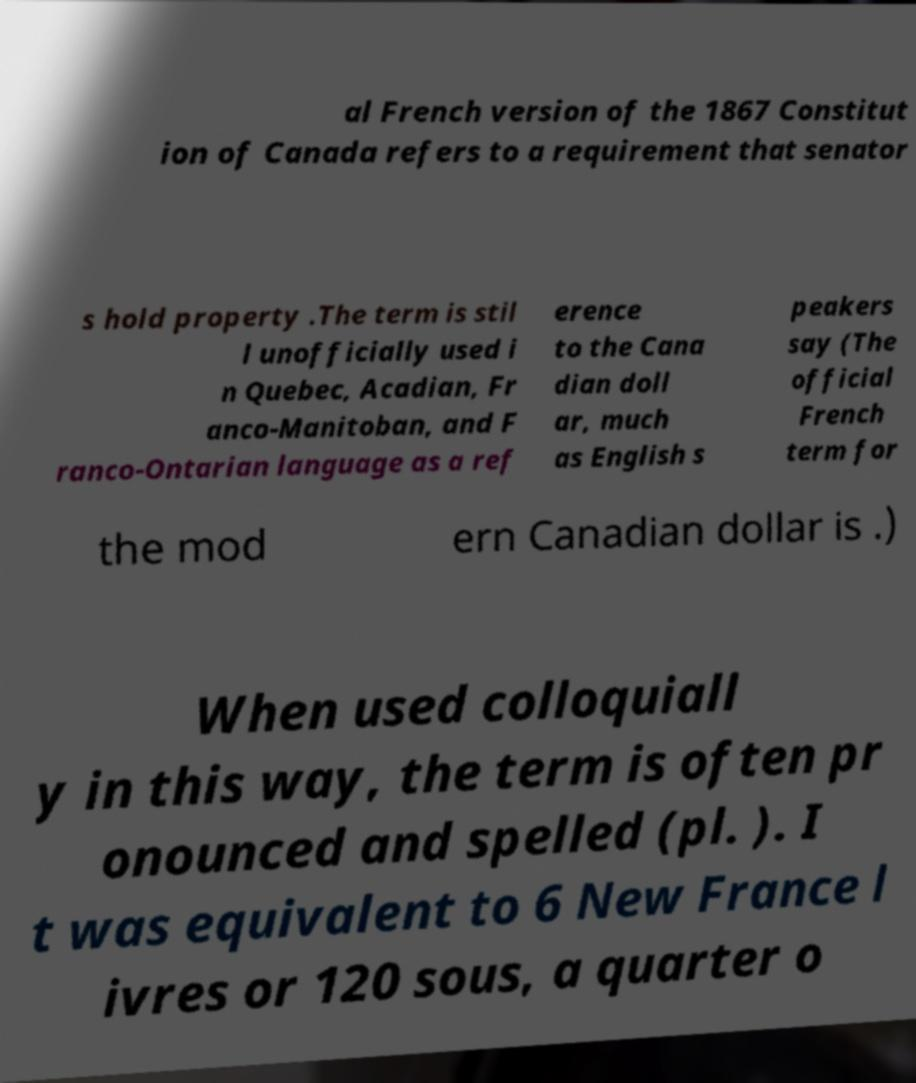Please read and relay the text visible in this image. What does it say? al French version of the 1867 Constitut ion of Canada refers to a requirement that senator s hold property .The term is stil l unofficially used i n Quebec, Acadian, Fr anco-Manitoban, and F ranco-Ontarian language as a ref erence to the Cana dian doll ar, much as English s peakers say (The official French term for the mod ern Canadian dollar is .) When used colloquiall y in this way, the term is often pr onounced and spelled (pl. ). I t was equivalent to 6 New France l ivres or 120 sous, a quarter o 